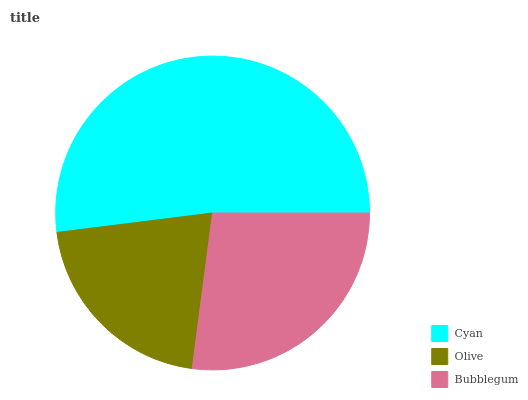Is Olive the minimum?
Answer yes or no. Yes. Is Cyan the maximum?
Answer yes or no. Yes. Is Bubblegum the minimum?
Answer yes or no. No. Is Bubblegum the maximum?
Answer yes or no. No. Is Bubblegum greater than Olive?
Answer yes or no. Yes. Is Olive less than Bubblegum?
Answer yes or no. Yes. Is Olive greater than Bubblegum?
Answer yes or no. No. Is Bubblegum less than Olive?
Answer yes or no. No. Is Bubblegum the high median?
Answer yes or no. Yes. Is Bubblegum the low median?
Answer yes or no. Yes. Is Olive the high median?
Answer yes or no. No. Is Olive the low median?
Answer yes or no. No. 